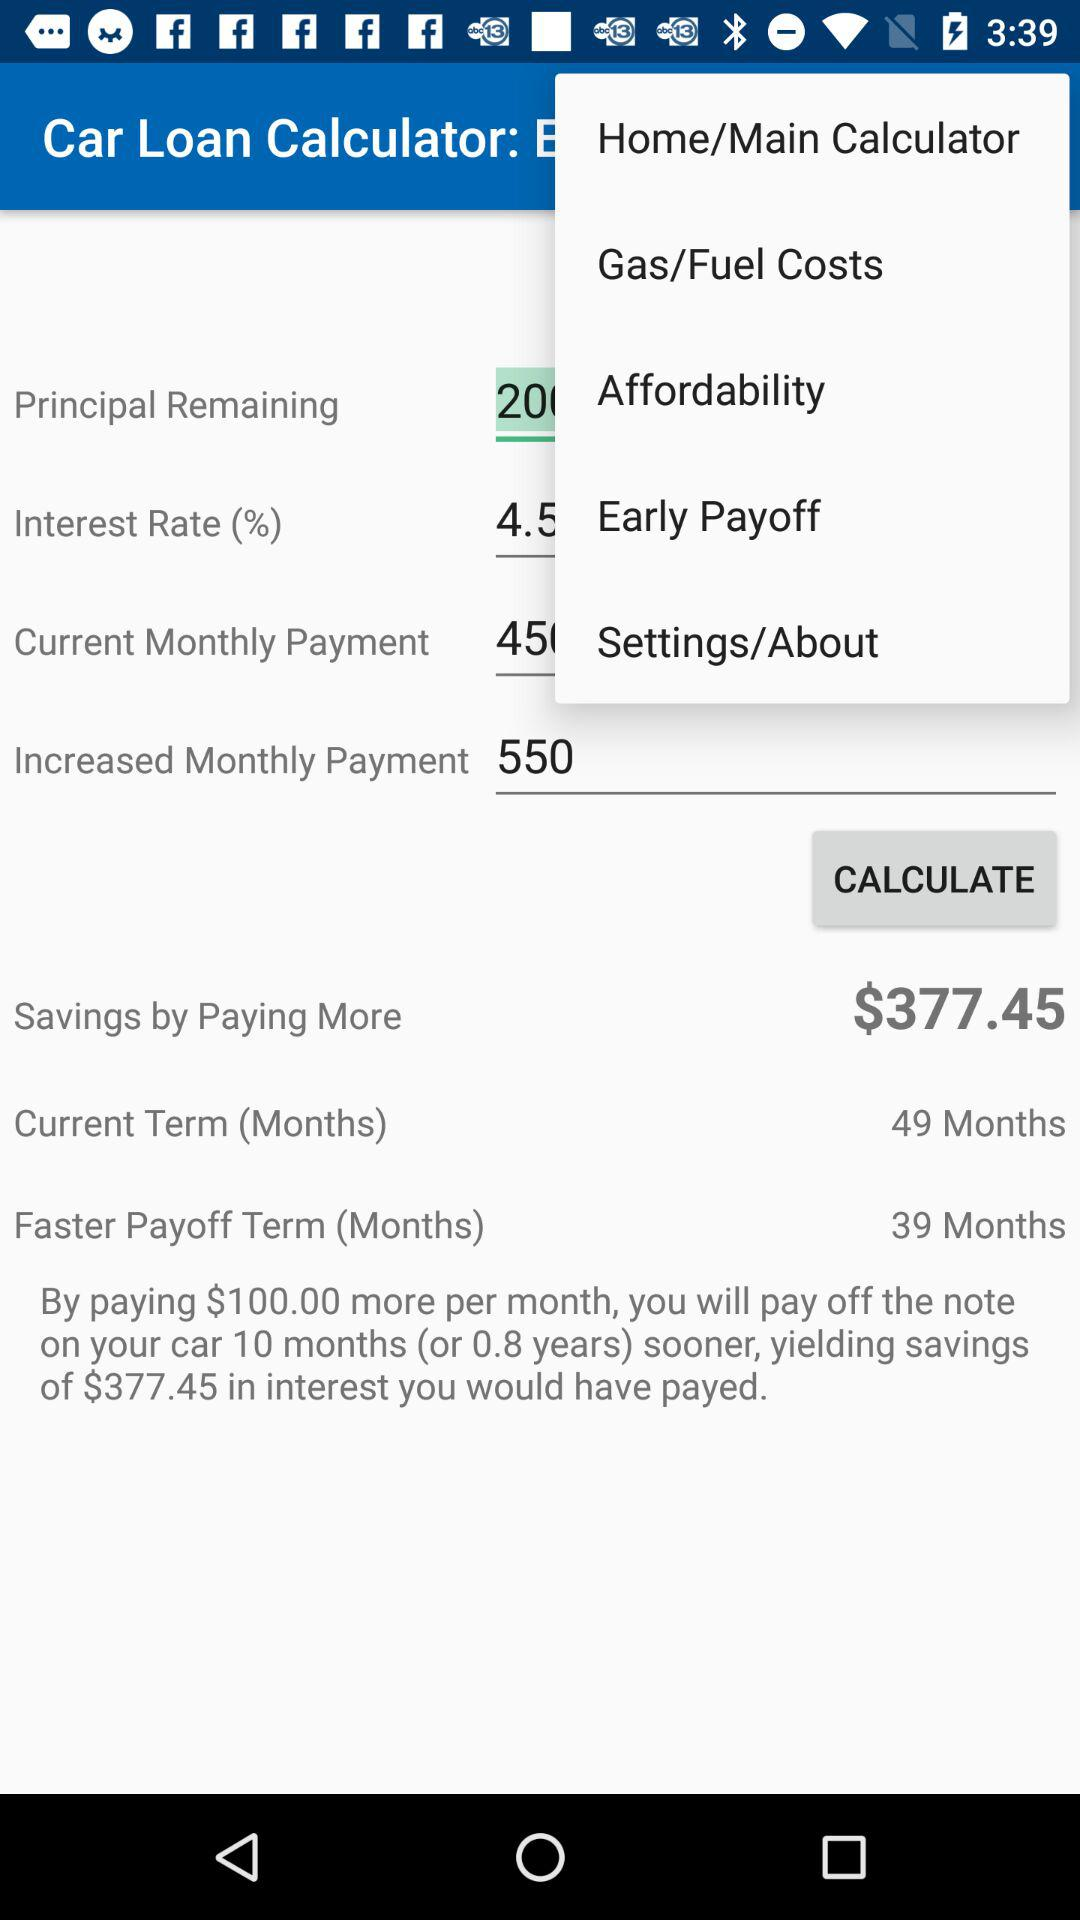How can I pay off the note on the car 10 months sooner? You can pay off the note on the car 10 months sooner by paying $100.00 more per month. 